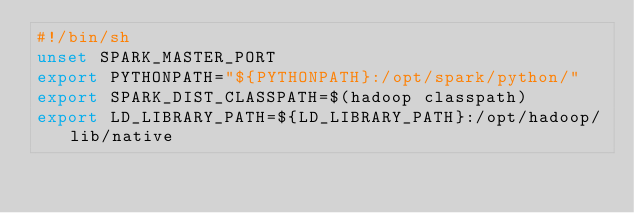<code> <loc_0><loc_0><loc_500><loc_500><_Bash_>#!/bin/sh
unset SPARK_MASTER_PORT
export PYTHONPATH="${PYTHONPATH}:/opt/spark/python/"
export SPARK_DIST_CLASSPATH=$(hadoop classpath)
export LD_LIBRARY_PATH=${LD_LIBRARY_PATH}:/opt/hadoop/lib/native</code> 